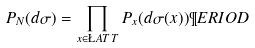Convert formula to latex. <formula><loc_0><loc_0><loc_500><loc_500>P _ { N } ( d \sigma ) = \prod _ { x \in \L A T T } P _ { x } ( d \sigma ( x ) ) \P E R I O D</formula> 